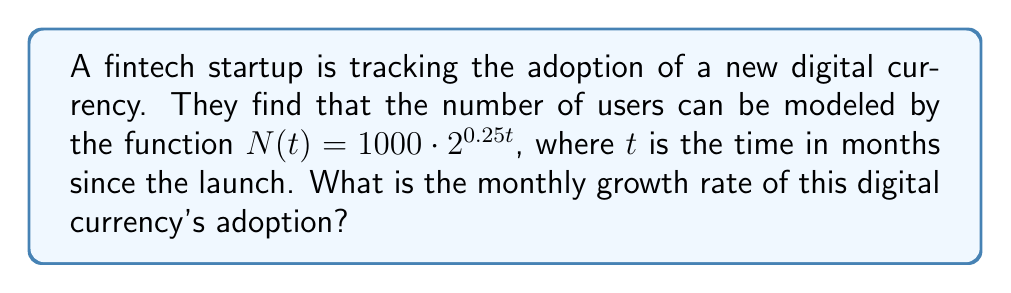Help me with this question. To determine the monthly growth rate, we need to analyze the exponential function given:

1) The general form of an exponential function is $f(t) = a \cdot b^t$, where $b$ is the growth factor.

2) In our case, $N(t) = 1000 \cdot 2^{0.25t}$

3) We can rewrite this as $N(t) = 1000 \cdot (2^{0.25})^t$

4) Now, $2^{0.25}$ is our growth factor per month.

5) To calculate the growth rate, we subtract 1 from the growth factor and multiply by 100:

   Growth rate = $(2^{0.25} - 1) \cdot 100\%$

6) Calculate $2^{0.25}$:
   $2^{0.25} \approx 1.1892$

7) Subtract 1 and multiply by 100:
   $(1.1892 - 1) \cdot 100\% \approx 18.92\%$

Therefore, the monthly growth rate is approximately 18.92%.
Answer: 18.92% 